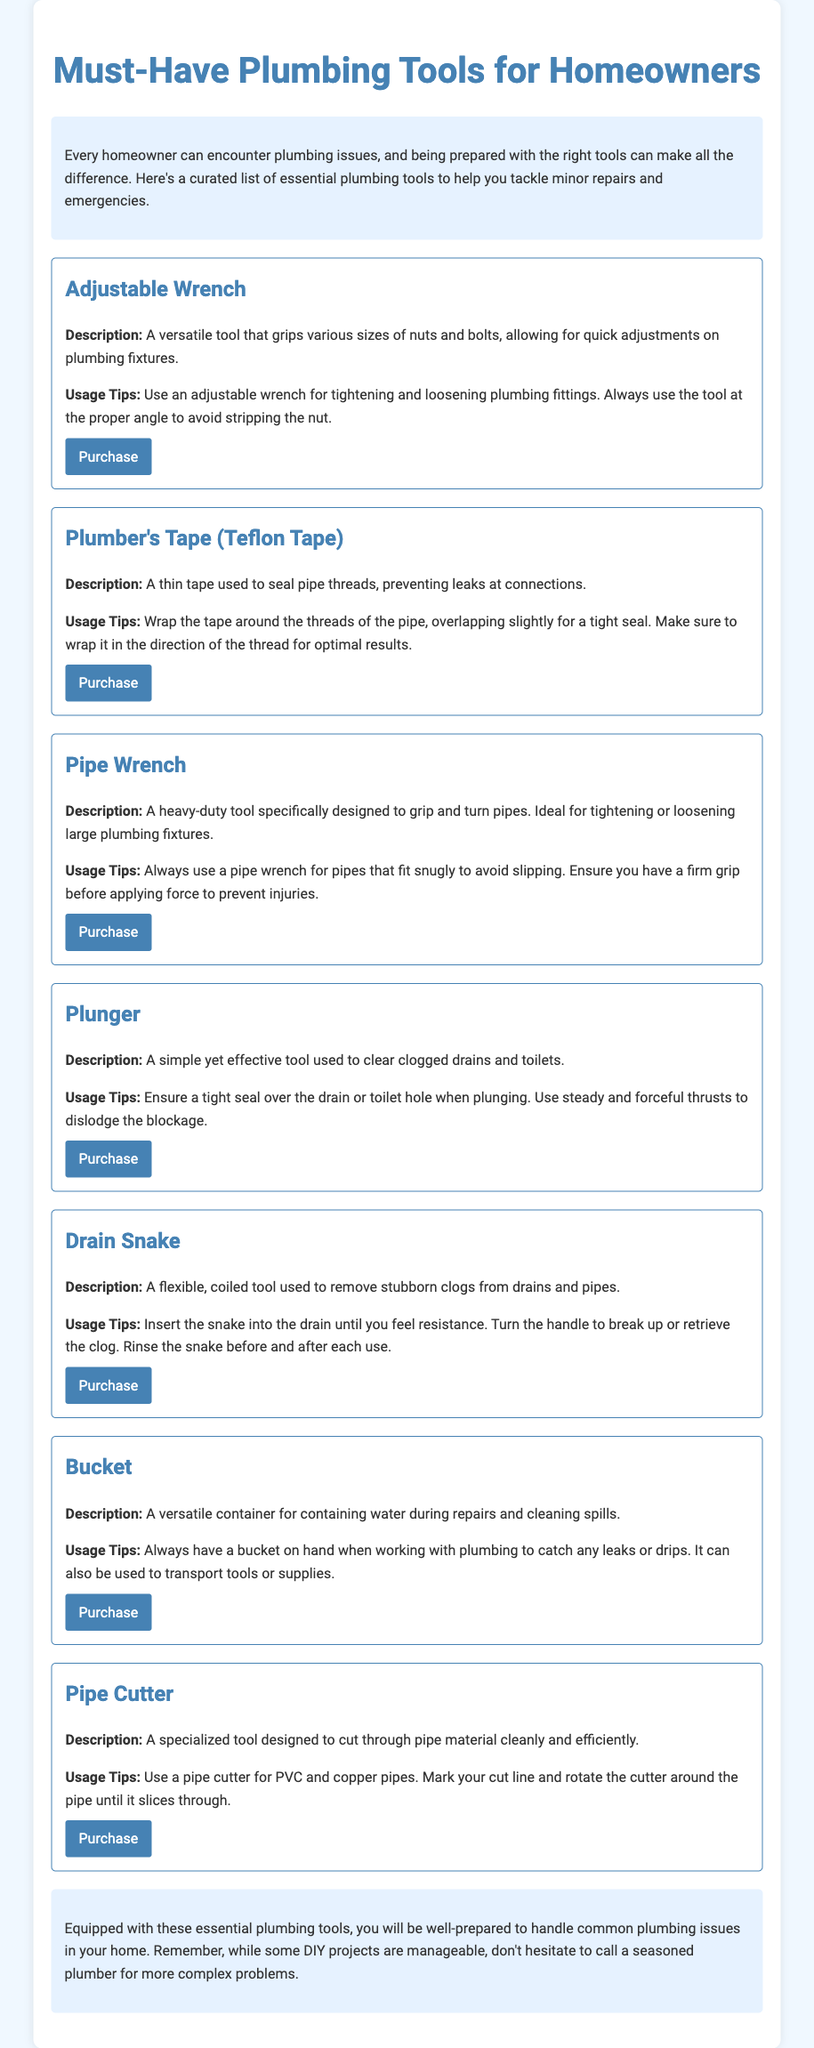What is the title of the document? The title of the document is presented prominently at the top of the page as the main heading.
Answer: Must-Have Plumbing Tools for Homeowners How many tools are listed in the document? The document contains a total of six essential plumbing tools for homeowners, as detailed in the tools section.
Answer: 7 What tool is used to seal pipe threads? The specific tool mentioned for sealing pipe threads is included in the tools list with its description.
Answer: Plumber's Tape What should you use to clear clogged drains? The document specifies a tool that is effectively used for clearing clogs, included in the tools section.
Answer: Plunger What is the usage tip for the Adjustable Wrench? A specific usage tip is provided for the Adjustable Wrench regarding how to use it properly for plumbing fixtures.
Answer: Use the tool at the proper angle What tool is recommended for cutting pipe material? The document names a specialized tool designed specifically for cutting pipes, focusing on its clean efficiency.
Answer: Pipe Cutter What color is used for the background of the container? The background color of the container is detailed in the style rules applied to the document layout.
Answer: White What is a recommended action for complex plumbing issues? The conclusion of the document provides advice on what to do for more complicated plumbing problems you might encounter.
Answer: Call a seasoned plumber 